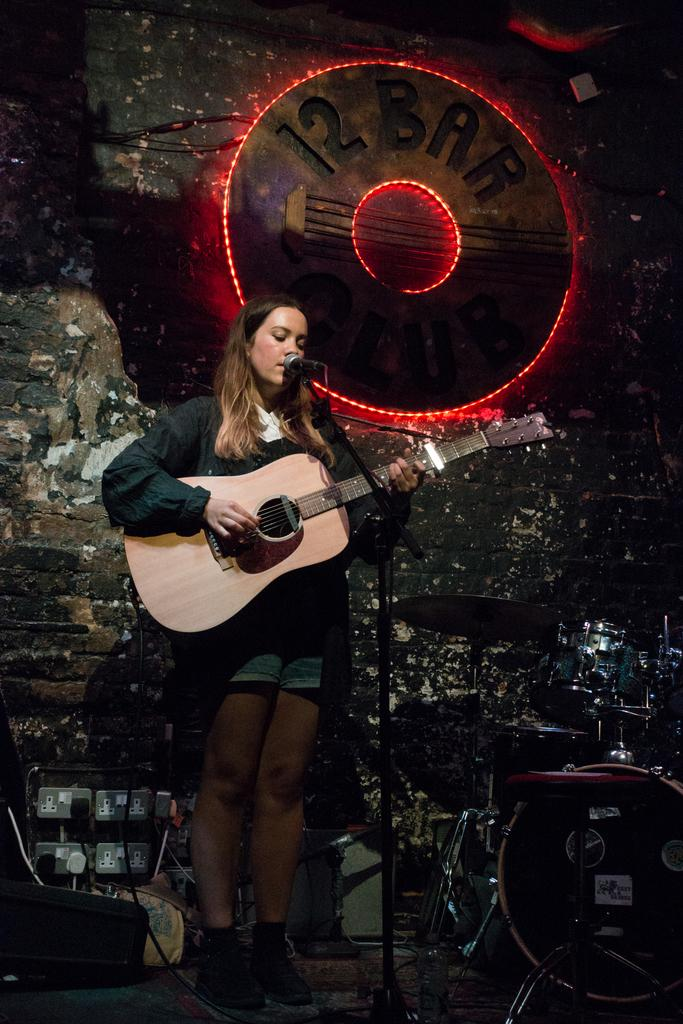What is the woman in the image holding? The woman is holding a guitar. What is the woman doing with the guitar? The woman is singing while holding the guitar. What is in front of the woman? There is a microphone in front of the woman. What can be seen in the background of the image? There is a board and a wall in the background of the image, as well as musical instruments. What type of jar is visible on the woman's wing in the image? There is no jar or wing present in the image; the woman is holding a guitar and standing in front of a microphone. 